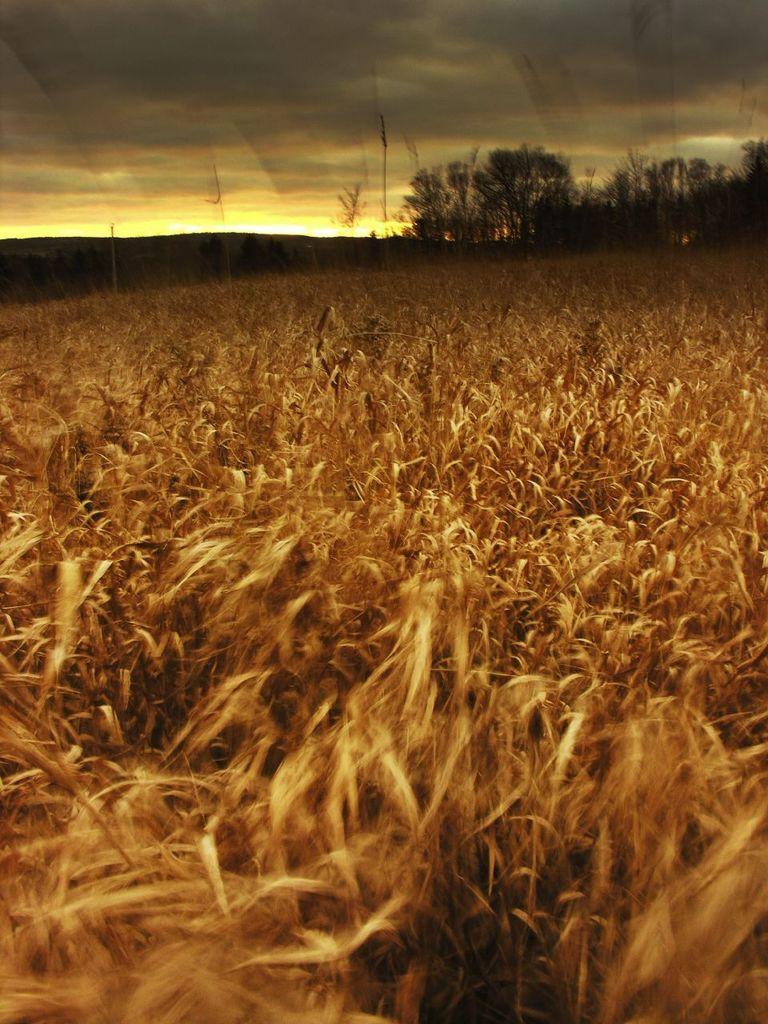Can you describe this image briefly? In this image in front there is a crop. In the background of the image there are trees, mountains and sky. 